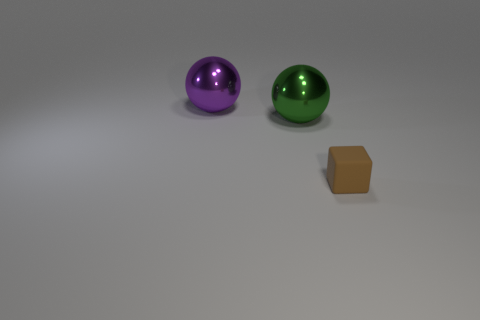What material is the big purple object that is the same shape as the large green thing?
Offer a terse response. Metal. What number of purple metal objects have the same size as the brown thing?
Offer a terse response. 0. What is the size of the purple sphere that is made of the same material as the big green sphere?
Your response must be concise. Large. What number of large green things have the same shape as the big purple metallic thing?
Keep it short and to the point. 1. How many big metallic objects are there?
Your response must be concise. 2. There is a metal object to the left of the big green shiny sphere; is it the same shape as the small thing?
Ensure brevity in your answer.  No. Are there any small cyan blocks made of the same material as the large green object?
Offer a terse response. No. Is the shape of the large purple object the same as the big green object that is to the right of the big purple metal object?
Offer a terse response. Yes. How many objects are in front of the large purple ball and to the left of the brown matte thing?
Provide a short and direct response. 1. Is the material of the large green object the same as the thing behind the green thing?
Provide a succinct answer. Yes. 